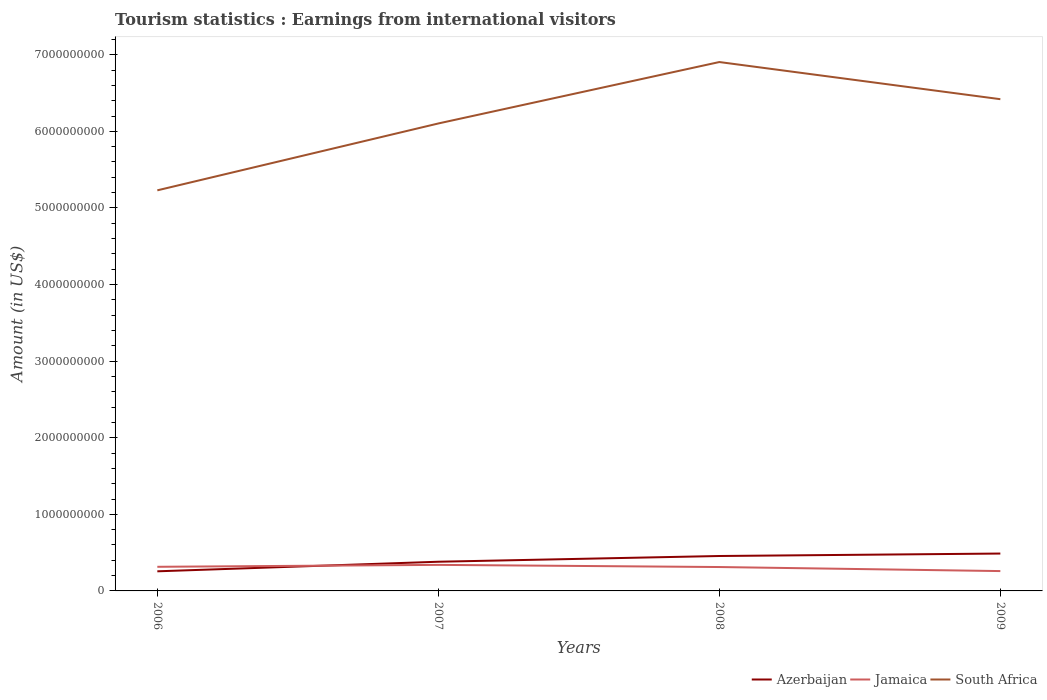Does the line corresponding to Azerbaijan intersect with the line corresponding to Jamaica?
Offer a terse response. Yes. Is the number of lines equal to the number of legend labels?
Ensure brevity in your answer.  Yes. Across all years, what is the maximum earnings from international visitors in Jamaica?
Offer a terse response. 2.59e+08. What is the total earnings from international visitors in South Africa in the graph?
Your answer should be very brief. -8.02e+08. What is the difference between the highest and the second highest earnings from international visitors in Azerbaijan?
Your response must be concise. 2.32e+08. What is the difference between the highest and the lowest earnings from international visitors in Azerbaijan?
Provide a short and direct response. 2. Is the earnings from international visitors in Jamaica strictly greater than the earnings from international visitors in Azerbaijan over the years?
Provide a short and direct response. No. How many lines are there?
Your answer should be compact. 3. Are the values on the major ticks of Y-axis written in scientific E-notation?
Offer a terse response. No. Does the graph contain any zero values?
Make the answer very short. No. Does the graph contain grids?
Ensure brevity in your answer.  No. What is the title of the graph?
Provide a short and direct response. Tourism statistics : Earnings from international visitors. What is the label or title of the Y-axis?
Provide a short and direct response. Amount (in US$). What is the Amount (in US$) in Azerbaijan in 2006?
Your answer should be very brief. 2.56e+08. What is the Amount (in US$) of Jamaica in 2006?
Your answer should be very brief. 3.15e+08. What is the Amount (in US$) in South Africa in 2006?
Your answer should be very brief. 5.23e+09. What is the Amount (in US$) of Azerbaijan in 2007?
Your response must be concise. 3.81e+08. What is the Amount (in US$) of Jamaica in 2007?
Provide a short and direct response. 3.40e+08. What is the Amount (in US$) in South Africa in 2007?
Offer a terse response. 6.10e+09. What is the Amount (in US$) in Azerbaijan in 2008?
Your answer should be compact. 4.56e+08. What is the Amount (in US$) of Jamaica in 2008?
Offer a terse response. 3.12e+08. What is the Amount (in US$) of South Africa in 2008?
Provide a succinct answer. 6.90e+09. What is the Amount (in US$) of Azerbaijan in 2009?
Ensure brevity in your answer.  4.88e+08. What is the Amount (in US$) in Jamaica in 2009?
Provide a succinct answer. 2.59e+08. What is the Amount (in US$) in South Africa in 2009?
Offer a terse response. 6.42e+09. Across all years, what is the maximum Amount (in US$) in Azerbaijan?
Offer a very short reply. 4.88e+08. Across all years, what is the maximum Amount (in US$) of Jamaica?
Provide a short and direct response. 3.40e+08. Across all years, what is the maximum Amount (in US$) of South Africa?
Provide a short and direct response. 6.90e+09. Across all years, what is the minimum Amount (in US$) of Azerbaijan?
Offer a terse response. 2.56e+08. Across all years, what is the minimum Amount (in US$) in Jamaica?
Ensure brevity in your answer.  2.59e+08. Across all years, what is the minimum Amount (in US$) of South Africa?
Your answer should be very brief. 5.23e+09. What is the total Amount (in US$) of Azerbaijan in the graph?
Your answer should be very brief. 1.58e+09. What is the total Amount (in US$) in Jamaica in the graph?
Your answer should be very brief. 1.23e+09. What is the total Amount (in US$) in South Africa in the graph?
Offer a very short reply. 2.47e+1. What is the difference between the Amount (in US$) in Azerbaijan in 2006 and that in 2007?
Keep it short and to the point. -1.25e+08. What is the difference between the Amount (in US$) of Jamaica in 2006 and that in 2007?
Give a very brief answer. -2.50e+07. What is the difference between the Amount (in US$) in South Africa in 2006 and that in 2007?
Your answer should be compact. -8.73e+08. What is the difference between the Amount (in US$) of Azerbaijan in 2006 and that in 2008?
Offer a terse response. -2.00e+08. What is the difference between the Amount (in US$) in South Africa in 2006 and that in 2008?
Offer a very short reply. -1.68e+09. What is the difference between the Amount (in US$) in Azerbaijan in 2006 and that in 2009?
Provide a succinct answer. -2.32e+08. What is the difference between the Amount (in US$) in Jamaica in 2006 and that in 2009?
Provide a succinct answer. 5.60e+07. What is the difference between the Amount (in US$) of South Africa in 2006 and that in 2009?
Provide a short and direct response. -1.19e+09. What is the difference between the Amount (in US$) of Azerbaijan in 2007 and that in 2008?
Offer a very short reply. -7.50e+07. What is the difference between the Amount (in US$) of Jamaica in 2007 and that in 2008?
Provide a short and direct response. 2.80e+07. What is the difference between the Amount (in US$) of South Africa in 2007 and that in 2008?
Your answer should be very brief. -8.02e+08. What is the difference between the Amount (in US$) of Azerbaijan in 2007 and that in 2009?
Ensure brevity in your answer.  -1.07e+08. What is the difference between the Amount (in US$) in Jamaica in 2007 and that in 2009?
Ensure brevity in your answer.  8.10e+07. What is the difference between the Amount (in US$) in South Africa in 2007 and that in 2009?
Provide a short and direct response. -3.17e+08. What is the difference between the Amount (in US$) in Azerbaijan in 2008 and that in 2009?
Your response must be concise. -3.20e+07. What is the difference between the Amount (in US$) in Jamaica in 2008 and that in 2009?
Keep it short and to the point. 5.30e+07. What is the difference between the Amount (in US$) of South Africa in 2008 and that in 2009?
Your answer should be very brief. 4.85e+08. What is the difference between the Amount (in US$) in Azerbaijan in 2006 and the Amount (in US$) in Jamaica in 2007?
Provide a short and direct response. -8.40e+07. What is the difference between the Amount (in US$) in Azerbaijan in 2006 and the Amount (in US$) in South Africa in 2007?
Provide a short and direct response. -5.85e+09. What is the difference between the Amount (in US$) of Jamaica in 2006 and the Amount (in US$) of South Africa in 2007?
Your response must be concise. -5.79e+09. What is the difference between the Amount (in US$) of Azerbaijan in 2006 and the Amount (in US$) of Jamaica in 2008?
Make the answer very short. -5.60e+07. What is the difference between the Amount (in US$) of Azerbaijan in 2006 and the Amount (in US$) of South Africa in 2008?
Make the answer very short. -6.65e+09. What is the difference between the Amount (in US$) in Jamaica in 2006 and the Amount (in US$) in South Africa in 2008?
Offer a very short reply. -6.59e+09. What is the difference between the Amount (in US$) in Azerbaijan in 2006 and the Amount (in US$) in Jamaica in 2009?
Your response must be concise. -3.00e+06. What is the difference between the Amount (in US$) in Azerbaijan in 2006 and the Amount (in US$) in South Africa in 2009?
Offer a terse response. -6.16e+09. What is the difference between the Amount (in US$) in Jamaica in 2006 and the Amount (in US$) in South Africa in 2009?
Provide a succinct answer. -6.10e+09. What is the difference between the Amount (in US$) in Azerbaijan in 2007 and the Amount (in US$) in Jamaica in 2008?
Provide a short and direct response. 6.90e+07. What is the difference between the Amount (in US$) in Azerbaijan in 2007 and the Amount (in US$) in South Africa in 2008?
Give a very brief answer. -6.52e+09. What is the difference between the Amount (in US$) in Jamaica in 2007 and the Amount (in US$) in South Africa in 2008?
Ensure brevity in your answer.  -6.56e+09. What is the difference between the Amount (in US$) of Azerbaijan in 2007 and the Amount (in US$) of Jamaica in 2009?
Keep it short and to the point. 1.22e+08. What is the difference between the Amount (in US$) in Azerbaijan in 2007 and the Amount (in US$) in South Africa in 2009?
Ensure brevity in your answer.  -6.04e+09. What is the difference between the Amount (in US$) of Jamaica in 2007 and the Amount (in US$) of South Africa in 2009?
Ensure brevity in your answer.  -6.08e+09. What is the difference between the Amount (in US$) of Azerbaijan in 2008 and the Amount (in US$) of Jamaica in 2009?
Provide a short and direct response. 1.97e+08. What is the difference between the Amount (in US$) in Azerbaijan in 2008 and the Amount (in US$) in South Africa in 2009?
Make the answer very short. -5.96e+09. What is the difference between the Amount (in US$) of Jamaica in 2008 and the Amount (in US$) of South Africa in 2009?
Ensure brevity in your answer.  -6.11e+09. What is the average Amount (in US$) in Azerbaijan per year?
Your answer should be very brief. 3.95e+08. What is the average Amount (in US$) of Jamaica per year?
Offer a very short reply. 3.06e+08. What is the average Amount (in US$) of South Africa per year?
Keep it short and to the point. 6.16e+09. In the year 2006, what is the difference between the Amount (in US$) in Azerbaijan and Amount (in US$) in Jamaica?
Give a very brief answer. -5.90e+07. In the year 2006, what is the difference between the Amount (in US$) of Azerbaijan and Amount (in US$) of South Africa?
Keep it short and to the point. -4.97e+09. In the year 2006, what is the difference between the Amount (in US$) in Jamaica and Amount (in US$) in South Africa?
Make the answer very short. -4.92e+09. In the year 2007, what is the difference between the Amount (in US$) of Azerbaijan and Amount (in US$) of Jamaica?
Ensure brevity in your answer.  4.10e+07. In the year 2007, what is the difference between the Amount (in US$) in Azerbaijan and Amount (in US$) in South Africa?
Provide a succinct answer. -5.72e+09. In the year 2007, what is the difference between the Amount (in US$) in Jamaica and Amount (in US$) in South Africa?
Make the answer very short. -5.76e+09. In the year 2008, what is the difference between the Amount (in US$) in Azerbaijan and Amount (in US$) in Jamaica?
Provide a succinct answer. 1.44e+08. In the year 2008, what is the difference between the Amount (in US$) of Azerbaijan and Amount (in US$) of South Africa?
Provide a succinct answer. -6.45e+09. In the year 2008, what is the difference between the Amount (in US$) of Jamaica and Amount (in US$) of South Africa?
Make the answer very short. -6.59e+09. In the year 2009, what is the difference between the Amount (in US$) of Azerbaijan and Amount (in US$) of Jamaica?
Offer a terse response. 2.29e+08. In the year 2009, what is the difference between the Amount (in US$) of Azerbaijan and Amount (in US$) of South Africa?
Your response must be concise. -5.93e+09. In the year 2009, what is the difference between the Amount (in US$) in Jamaica and Amount (in US$) in South Africa?
Ensure brevity in your answer.  -6.16e+09. What is the ratio of the Amount (in US$) of Azerbaijan in 2006 to that in 2007?
Make the answer very short. 0.67. What is the ratio of the Amount (in US$) in Jamaica in 2006 to that in 2007?
Your response must be concise. 0.93. What is the ratio of the Amount (in US$) of South Africa in 2006 to that in 2007?
Your response must be concise. 0.86. What is the ratio of the Amount (in US$) in Azerbaijan in 2006 to that in 2008?
Your answer should be very brief. 0.56. What is the ratio of the Amount (in US$) of Jamaica in 2006 to that in 2008?
Offer a very short reply. 1.01. What is the ratio of the Amount (in US$) of South Africa in 2006 to that in 2008?
Your response must be concise. 0.76. What is the ratio of the Amount (in US$) in Azerbaijan in 2006 to that in 2009?
Provide a short and direct response. 0.52. What is the ratio of the Amount (in US$) in Jamaica in 2006 to that in 2009?
Your response must be concise. 1.22. What is the ratio of the Amount (in US$) in South Africa in 2006 to that in 2009?
Your answer should be very brief. 0.81. What is the ratio of the Amount (in US$) in Azerbaijan in 2007 to that in 2008?
Provide a succinct answer. 0.84. What is the ratio of the Amount (in US$) of Jamaica in 2007 to that in 2008?
Your response must be concise. 1.09. What is the ratio of the Amount (in US$) in South Africa in 2007 to that in 2008?
Offer a terse response. 0.88. What is the ratio of the Amount (in US$) of Azerbaijan in 2007 to that in 2009?
Offer a terse response. 0.78. What is the ratio of the Amount (in US$) of Jamaica in 2007 to that in 2009?
Your answer should be very brief. 1.31. What is the ratio of the Amount (in US$) of South Africa in 2007 to that in 2009?
Offer a very short reply. 0.95. What is the ratio of the Amount (in US$) of Azerbaijan in 2008 to that in 2009?
Your response must be concise. 0.93. What is the ratio of the Amount (in US$) in Jamaica in 2008 to that in 2009?
Your response must be concise. 1.2. What is the ratio of the Amount (in US$) in South Africa in 2008 to that in 2009?
Provide a succinct answer. 1.08. What is the difference between the highest and the second highest Amount (in US$) of Azerbaijan?
Your answer should be compact. 3.20e+07. What is the difference between the highest and the second highest Amount (in US$) in Jamaica?
Provide a short and direct response. 2.50e+07. What is the difference between the highest and the second highest Amount (in US$) in South Africa?
Your response must be concise. 4.85e+08. What is the difference between the highest and the lowest Amount (in US$) of Azerbaijan?
Your answer should be very brief. 2.32e+08. What is the difference between the highest and the lowest Amount (in US$) in Jamaica?
Offer a terse response. 8.10e+07. What is the difference between the highest and the lowest Amount (in US$) of South Africa?
Offer a terse response. 1.68e+09. 